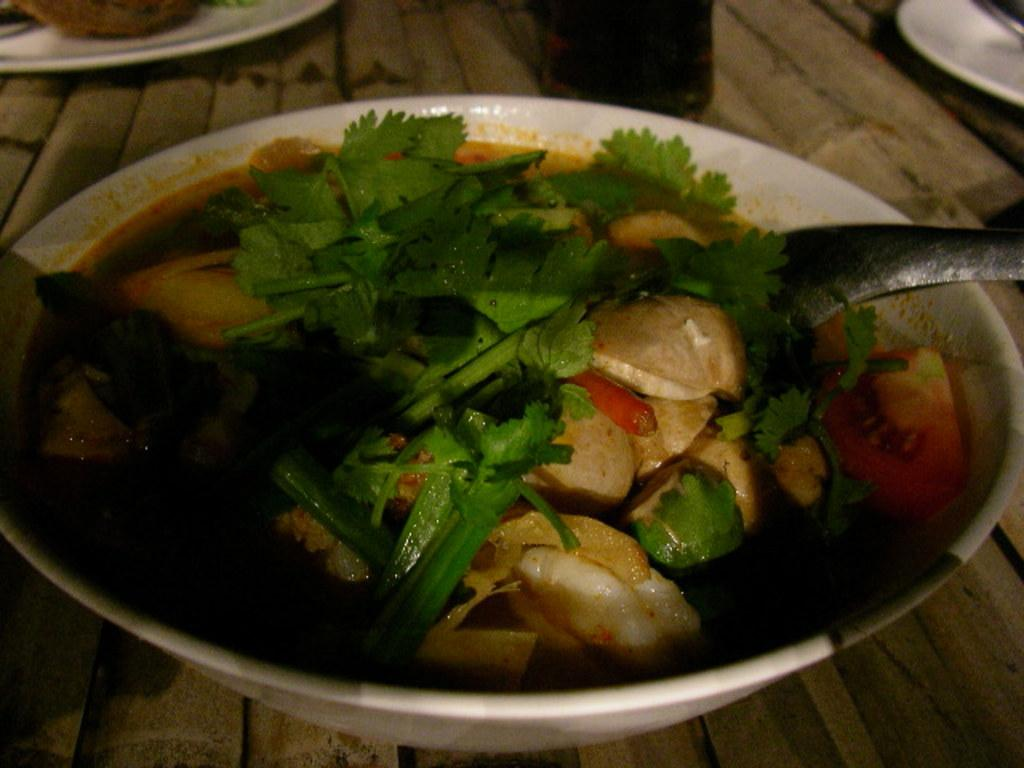What piece of furniture is present in the image? There is a table in the image. What is placed on the table? There is a bowl on the table. What is inside the bowl? The bowl contains food items. What utensil is used to eat the food in the bowl? There is a spoon in the bowl. What other tableware can be seen in the image? There are plates visible in the background of the image. What type of nail is being hammered into the alley in the image? There is no nail or alley present in the image; it features a table with a bowl, spoon, and plates. 